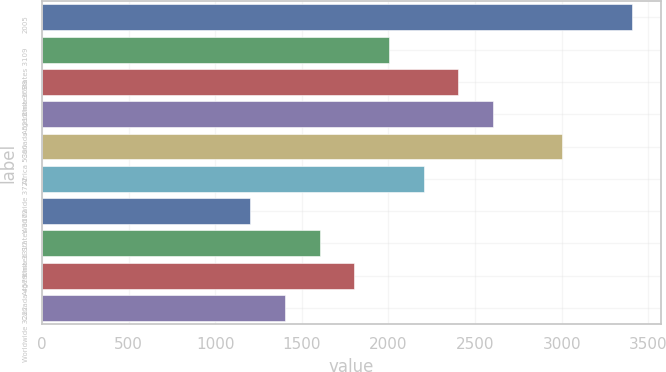Convert chart to OTSL. <chart><loc_0><loc_0><loc_500><loc_500><bar_chart><fcel>2005<fcel>United States 3109<fcel>Argentina 3688<fcel>Canada 5212<fcel>Africa 5300<fcel>Worldwide 3722<fcel>United States 3172<fcel>Argentina 3317<fcel>Canada 4579<fcel>Worldwide 3222<nl><fcel>3404.64<fcel>2002.96<fcel>2403.44<fcel>2603.68<fcel>3004.16<fcel>2203.2<fcel>1202<fcel>1602.48<fcel>1802.72<fcel>1402.24<nl></chart> 